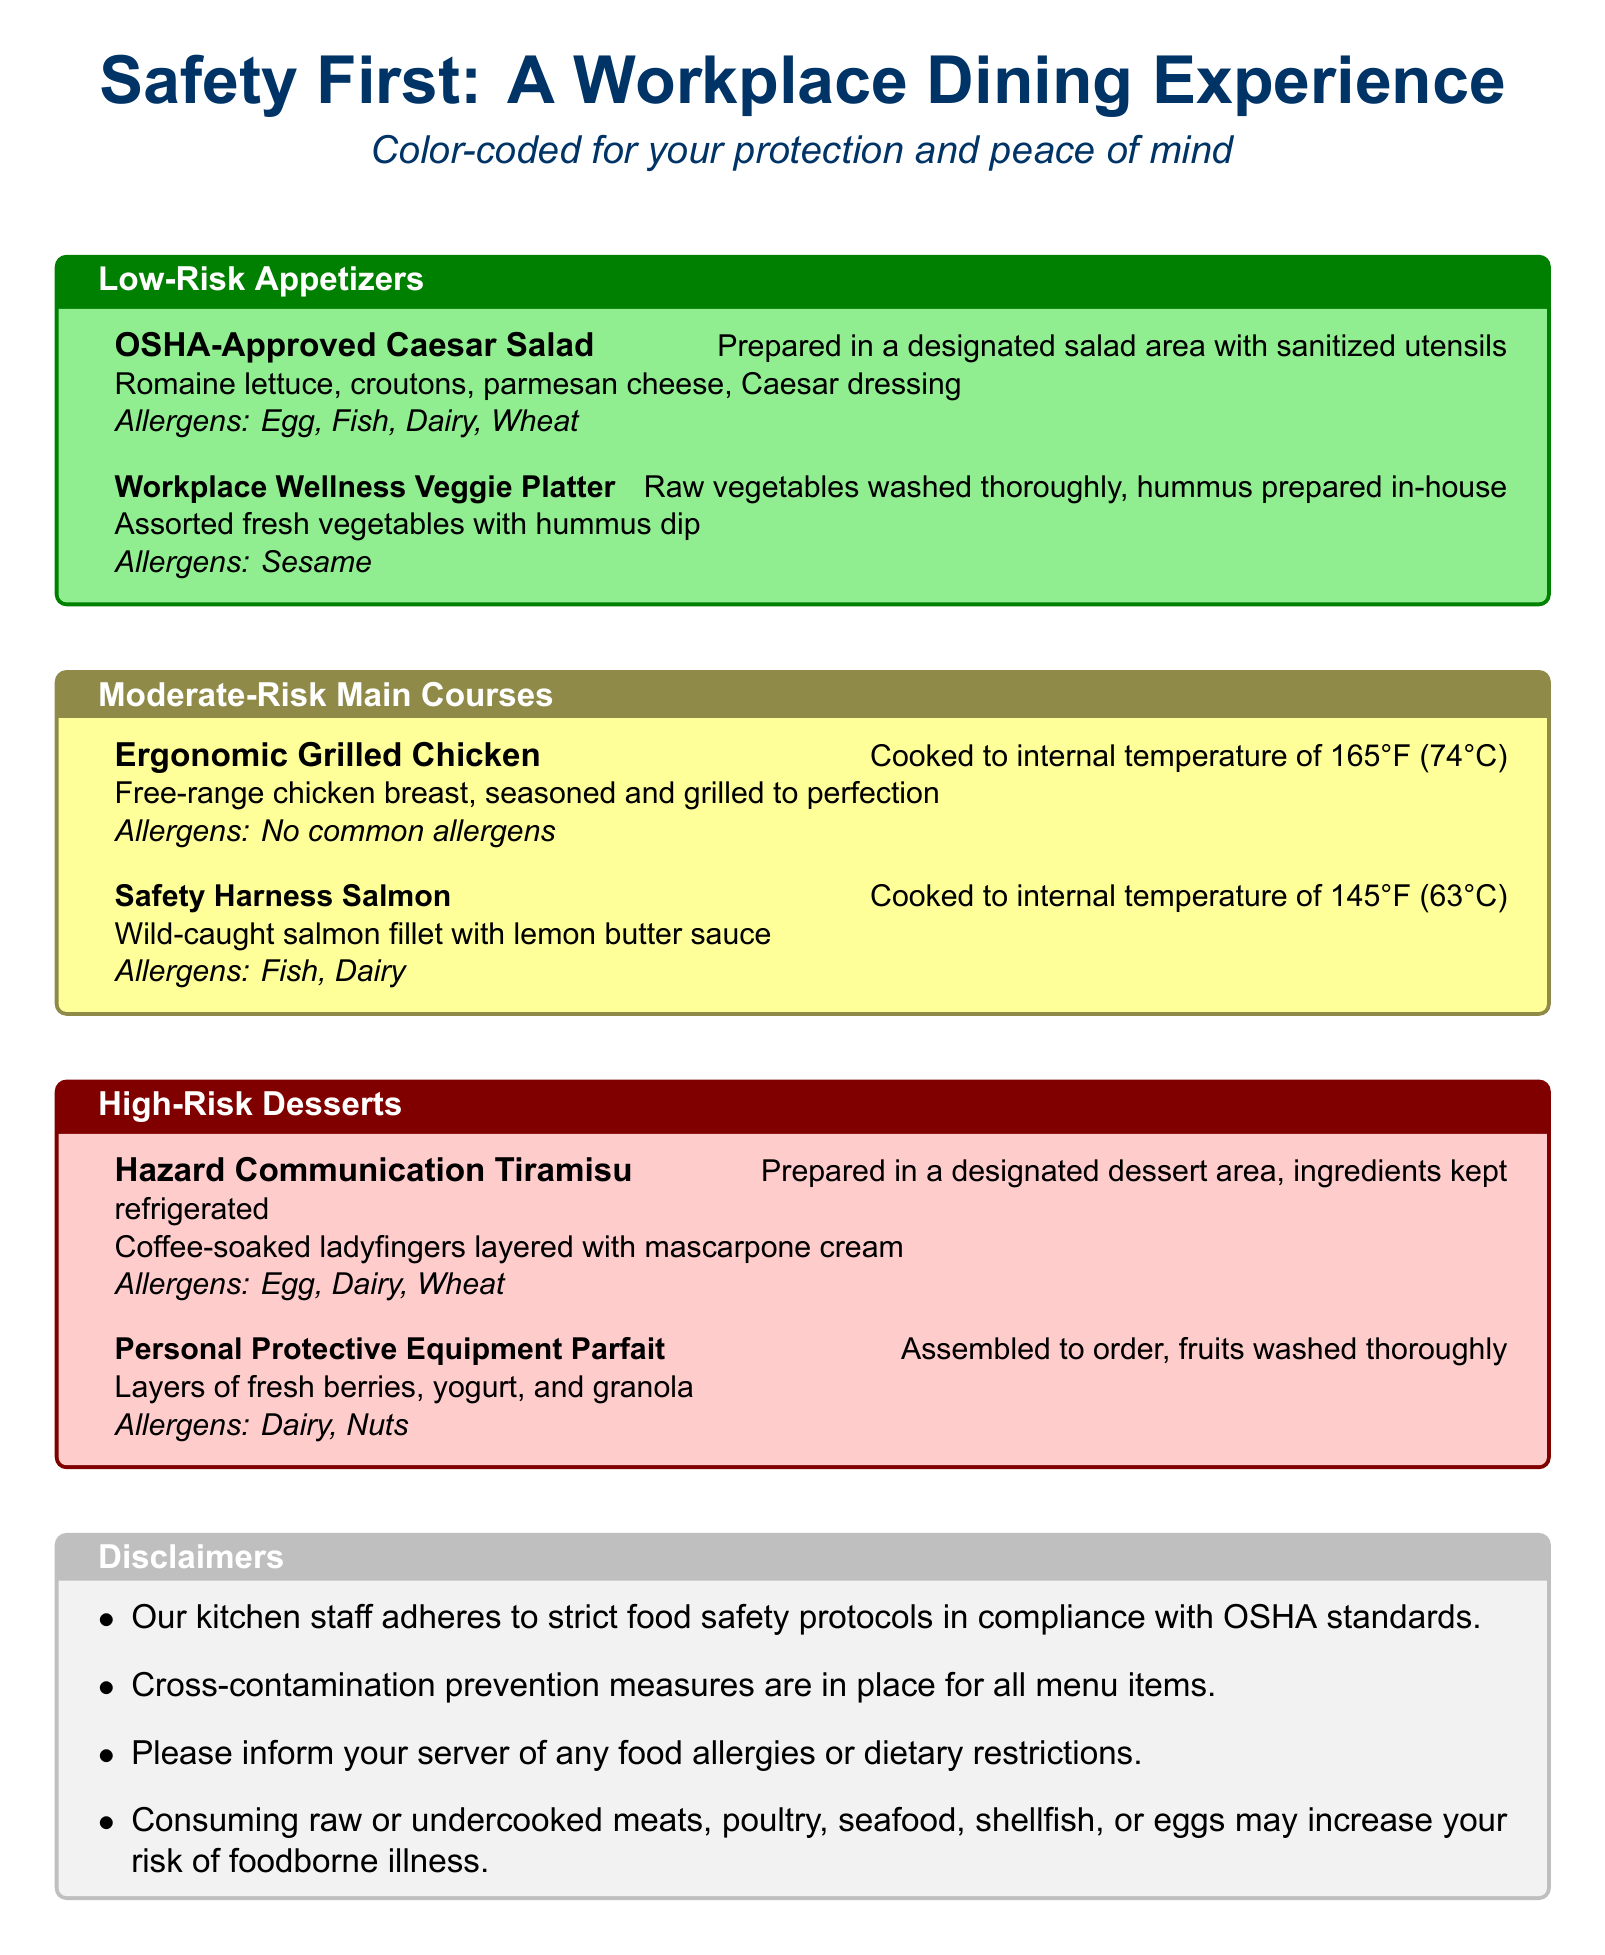What are the ingredients in the OSHA-Approved Caesar Salad? The ingredients are listed as Romaine lettuce, croutons, parmesan cheese, and Caesar dressing.
Answer: Romaine lettuce, croutons, parmesan cheese, Caesar dressing What allergens are in the Hazard Communication Tiramisu? The allergens are specified under the dessert item in the menu.
Answer: Egg, Dairy, Wheat What is the cooking temperature for the Ergonomic Grilled Chicken? The cooking temperature is stated in the preparation method for that dish.
Answer: 165°F (74°C) Which dessert has nuts as an allergen? The allergens for each dessert are listed, allowing identification of the one that includes nuts.
Answer: Personal Protective Equipment Parfait What is the risk level of the Safety Harness Salmon? The risk levels are indicated by the color-coding of cuisine sections in the menu.
Answer: Moderate-Risk What type of platter is included in the Low-Risk Appetizers? This information can be found in the appetizers section, clarifying the type of dish.
Answer: Workplace Wellness Veggie Platter How many items are listed under High-Risk Desserts? The number of items can be counted in the dessert section of the menu.
Answer: 2 Which dish contains fish as an allergen? The allergens are listed for each dish, helping to determine which one includes fish.
Answer: Safety Harness Salmon What is the purpose of the color-coded sections in the menu? The menu specifies that the color-coded sections help represent different risk levels for the diners.
Answer: Safety and protection 